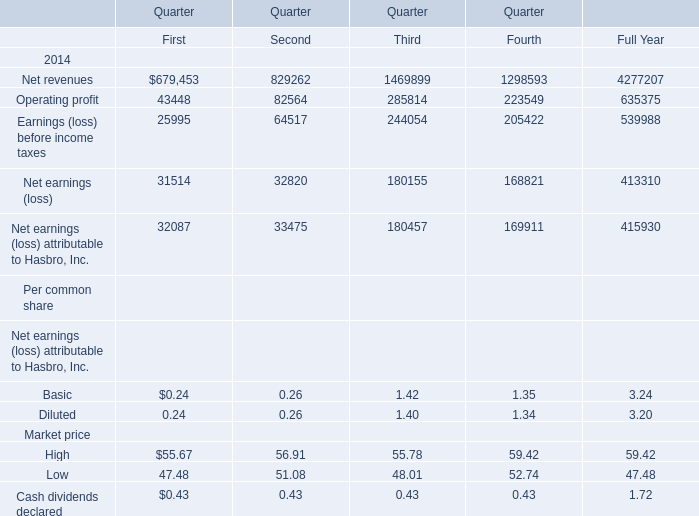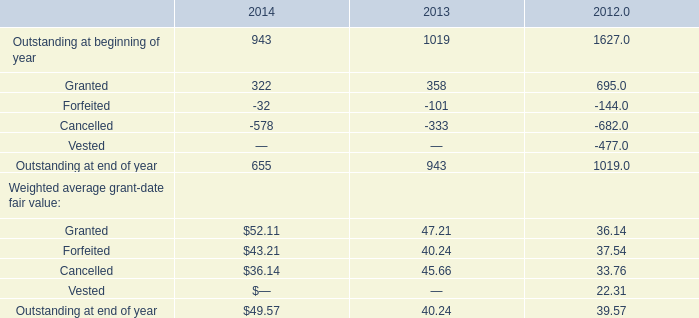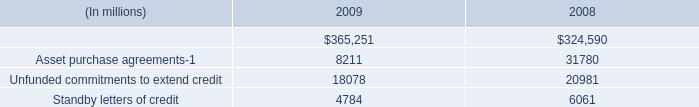Which quarter is Operating profit the highest in 2014? 
Answer: 3. 